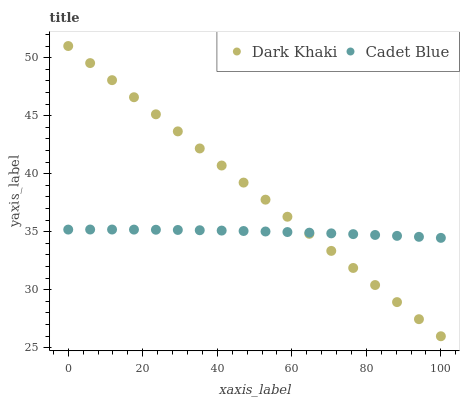Does Cadet Blue have the minimum area under the curve?
Answer yes or no. Yes. Does Dark Khaki have the maximum area under the curve?
Answer yes or no. Yes. Does Cadet Blue have the maximum area under the curve?
Answer yes or no. No. Is Dark Khaki the smoothest?
Answer yes or no. Yes. Is Cadet Blue the roughest?
Answer yes or no. Yes. Is Cadet Blue the smoothest?
Answer yes or no. No. Does Dark Khaki have the lowest value?
Answer yes or no. Yes. Does Cadet Blue have the lowest value?
Answer yes or no. No. Does Dark Khaki have the highest value?
Answer yes or no. Yes. Does Cadet Blue have the highest value?
Answer yes or no. No. Does Dark Khaki intersect Cadet Blue?
Answer yes or no. Yes. Is Dark Khaki less than Cadet Blue?
Answer yes or no. No. Is Dark Khaki greater than Cadet Blue?
Answer yes or no. No. 